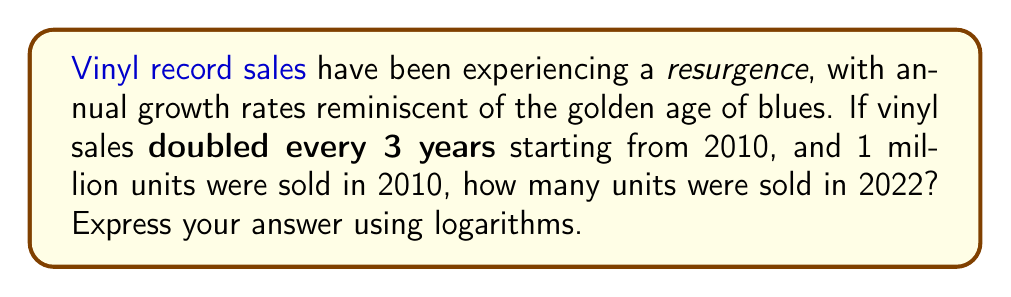Could you help me with this problem? Let's approach this step-by-step:

1) First, we need to determine how many 3-year periods have passed from 2010 to 2022:
   $\frac{2022 - 2010}{3} = 4$ periods

2) We're dealing with exponential growth, where the sales double every period. This can be expressed as:

   $$S = S_0 \cdot 2^n$$

   Where $S$ is the final sales, $S_0$ is the initial sales, and $n$ is the number of periods.

3) We know:
   $S_0 = 1$ million (initial sales in 2010)
   $n = 4$ (number of 3-year periods)

4) Plugging these into our equation:

   $$S = 1 \cdot 2^4 = 16$$ million

5) To express this using logarithms, we can use the property:

   $$\log_a(x^n) = n\log_a(x)$$

6) Taking the logarithm (base 2) of both sides of our equation:

   $$\log_2(S) = \log_2(1 \cdot 2^4) = \log_2(1) + 4\log_2(2) = 0 + 4 \cdot 1 = 4$$

7) Therefore, we can express our answer as:

   $$S = 2^{\log_2(S)} = 2^4 = 16$$ million
Answer: $2^{\log_2(16)}$ million 